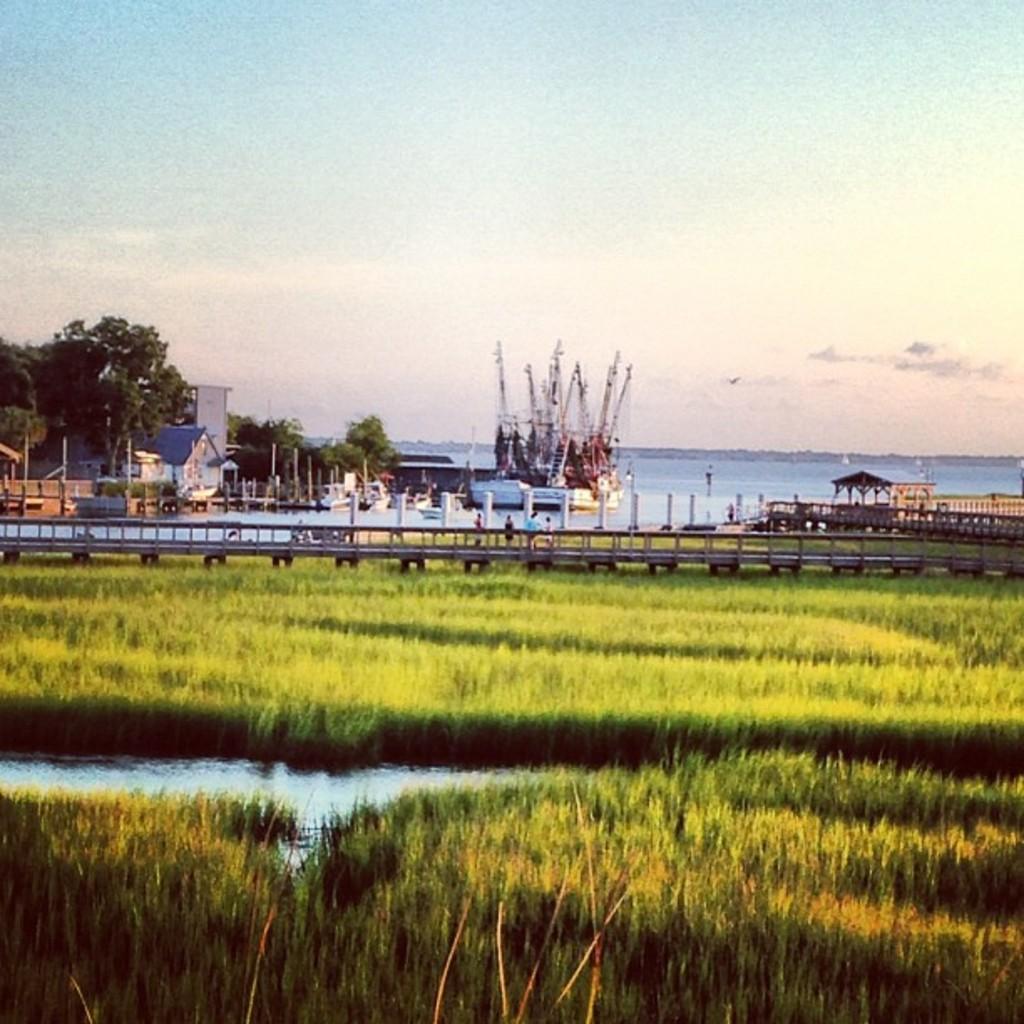Describe this image in one or two sentences. This is grass and there is a bridge. Here we can see trees, poles, house, ship, and water. In the background there is sky. 